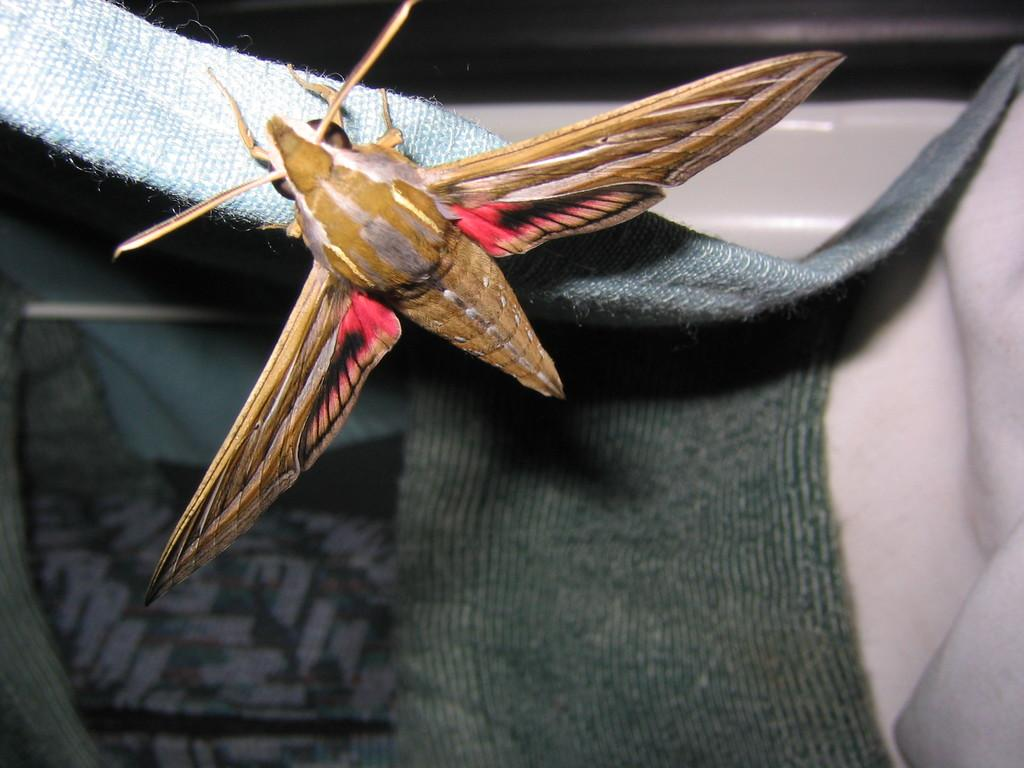What type of creature is present in the image? There is an insect in the image. What is the insect resting on? The insect is on some cloth. In which direction is the throne facing in the image? There is no throne present in the image. What type of curtain can be seen in the image? There is no curtain present in the image. 